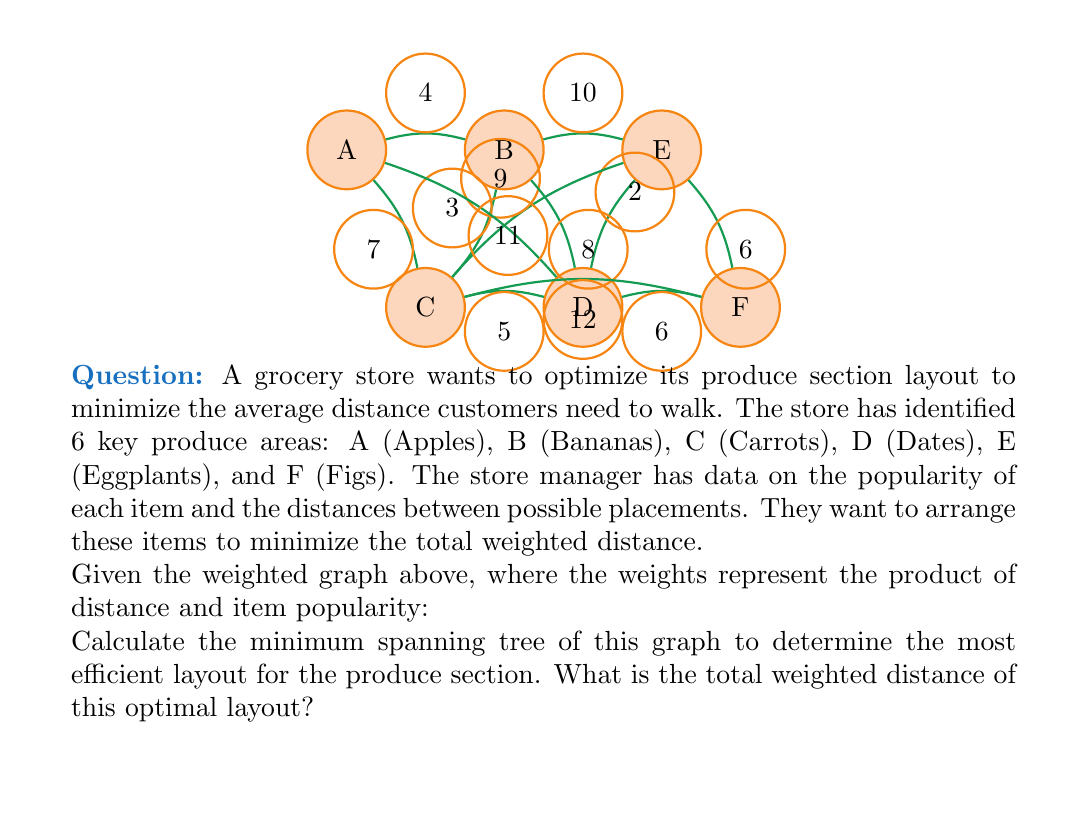Teach me how to tackle this problem. To find the most efficient layout, we need to calculate the minimum spanning tree (MST) of the given graph. We'll use Kruskal's algorithm to find the MST:

1) Sort all edges by weight in ascending order:
   D-E (2), B-C (3), A-B (4), C-D (5), D-F (6), E-F (6), A-C (7), B-D (8), C-E (9), B-E (10), A-D (11), C-F (12)

2) Start with an empty set of edges and add edges one by one, skipping those that would create a cycle:

   - Add D-E (2)
   - Add B-C (3)
   - Add A-B (4)
   - Add C-D (5)
   - Add D-F (6) or E-F (6) (let's choose D-F)

3) We now have 5 edges, which is sufficient for a minimum spanning tree of a 6-node graph.

4) The final MST consists of these edges: D-E, B-C, A-B, C-D, D-F

5) Calculate the total weighted distance by summing the weights of these edges:

   $$ \text{Total weighted distance} = 2 + 3 + 4 + 5 + 6 = 20 $$

Therefore, the most efficient layout for the produce section has a total weighted distance of 20.
Answer: 20 